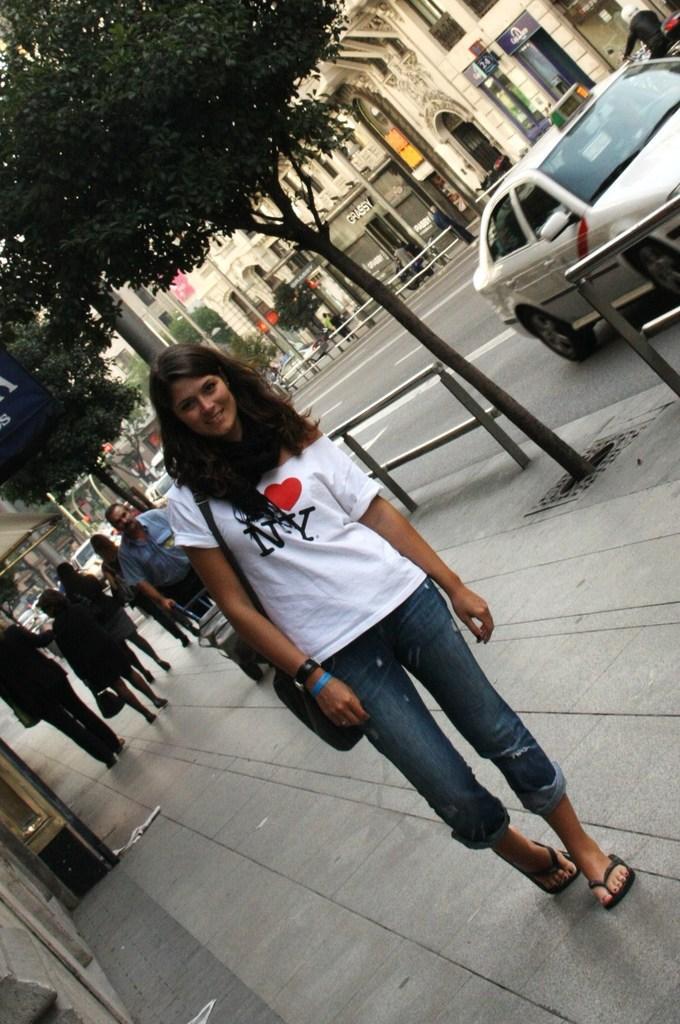Please provide a concise description of this image. In the picture I can see a woman wearing white color T-shirt and jeans is carrying a bag and standing on the sidewalk. In the background, we can see a few more people walking on the sidewalk, we can see a car moving on the road, we can see trees, poles, a few more vehicles moving on the road and buildings in the background. 